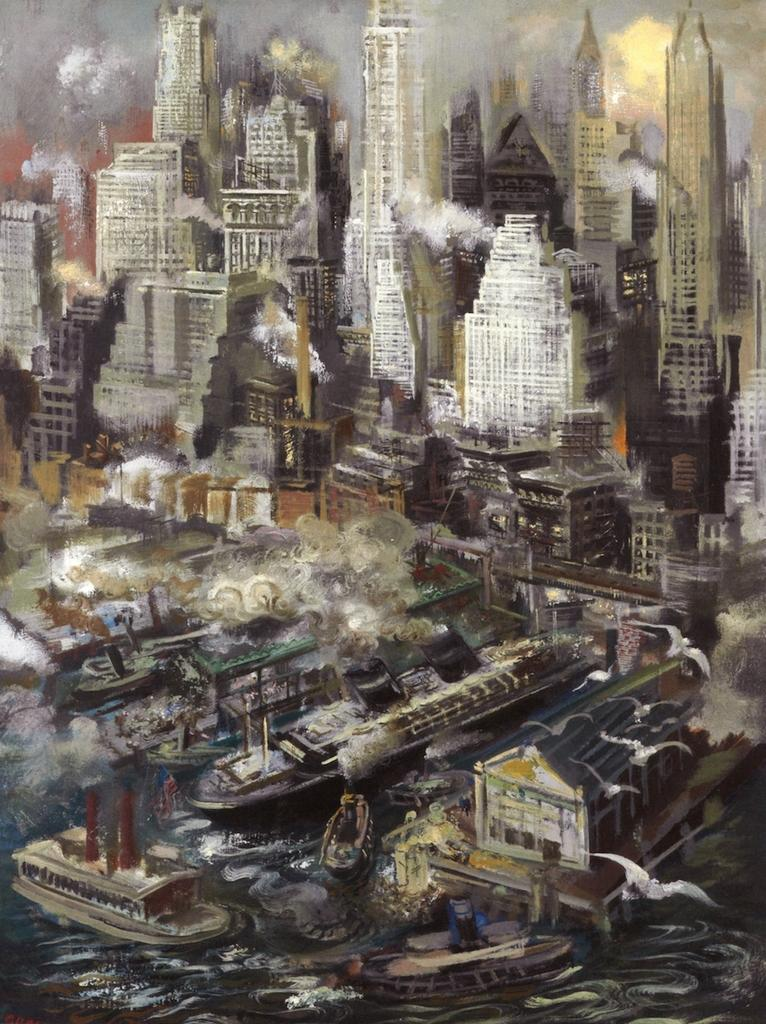What is the main subject of the image? There is a painting in the image. What type of structures can be seen in the painting? There are buildings in the image. What type of vehicles are present in the painting? There are boats and ships in the image. Where is the vase located in the image? There is no vase present in the image. What type of ball is being used by the people in the image? There are no people or balls present in the image. 